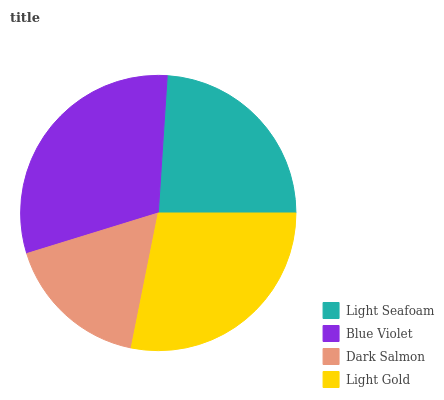Is Dark Salmon the minimum?
Answer yes or no. Yes. Is Blue Violet the maximum?
Answer yes or no. Yes. Is Blue Violet the minimum?
Answer yes or no. No. Is Dark Salmon the maximum?
Answer yes or no. No. Is Blue Violet greater than Dark Salmon?
Answer yes or no. Yes. Is Dark Salmon less than Blue Violet?
Answer yes or no. Yes. Is Dark Salmon greater than Blue Violet?
Answer yes or no. No. Is Blue Violet less than Dark Salmon?
Answer yes or no. No. Is Light Gold the high median?
Answer yes or no. Yes. Is Light Seafoam the low median?
Answer yes or no. Yes. Is Blue Violet the high median?
Answer yes or no. No. Is Dark Salmon the low median?
Answer yes or no. No. 